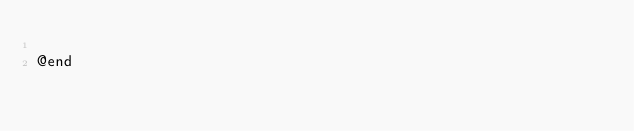<code> <loc_0><loc_0><loc_500><loc_500><_C_>
@end
</code> 